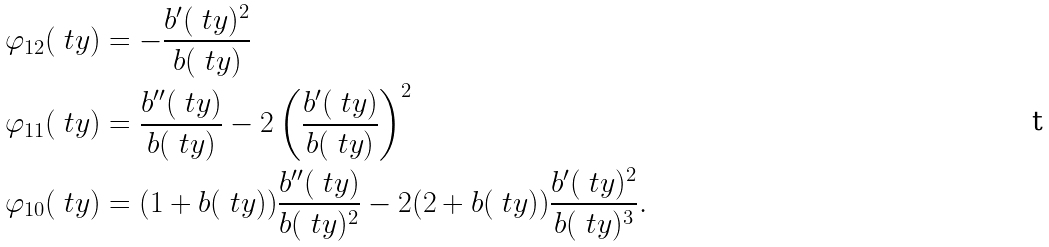Convert formula to latex. <formula><loc_0><loc_0><loc_500><loc_500>\varphi _ { 1 2 } ( \ t y ) & = - \frac { b ^ { \prime } ( \ t y ) ^ { 2 } } { b ( \ t y ) } \\ \varphi _ { 1 1 } ( \ t y ) & = \frac { b ^ { \prime \prime } ( \ t y ) } { b ( \ t y ) } - 2 \left ( \frac { b ^ { \prime } ( \ t y ) } { b ( \ t y ) } \right ) ^ { 2 } \\ \varphi _ { 1 0 } ( \ t y ) & = ( 1 + b ( \ t y ) ) \frac { b ^ { \prime \prime } ( \ t y ) } { b ( \ t y ) ^ { 2 } } - 2 ( 2 + b ( \ t y ) ) \frac { b ^ { \prime } ( \ t y ) ^ { 2 } } { b ( \ t y ) ^ { 3 } } .</formula> 